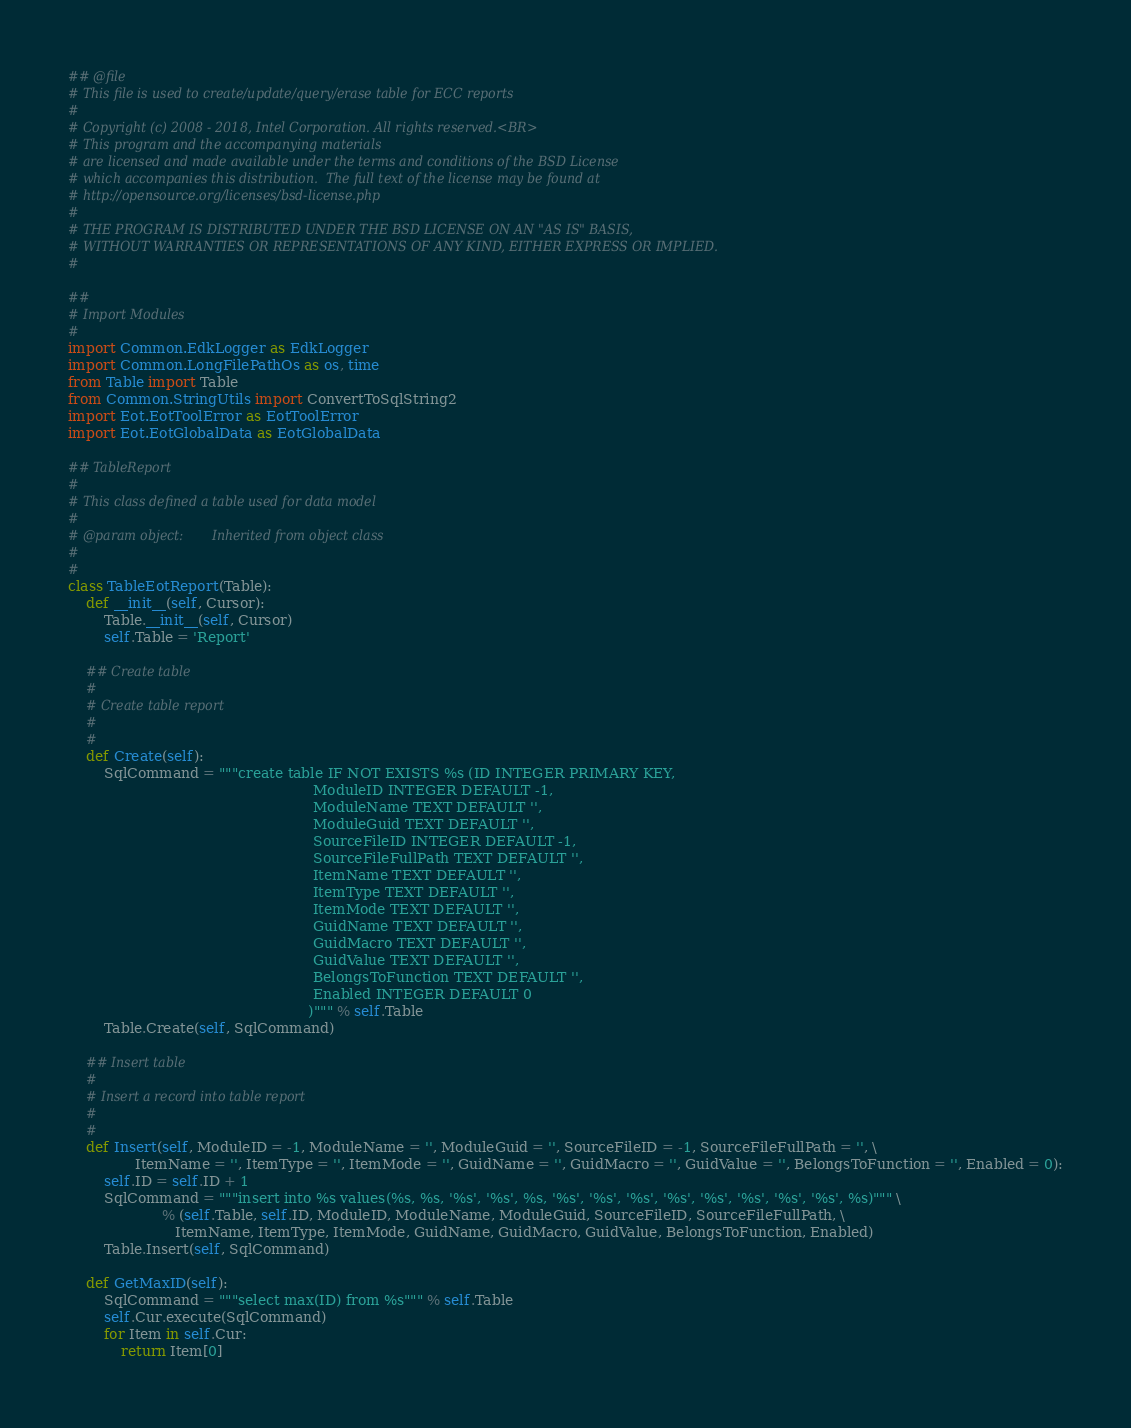Convert code to text. <code><loc_0><loc_0><loc_500><loc_500><_Python_>## @file
# This file is used to create/update/query/erase table for ECC reports
#
# Copyright (c) 2008 - 2018, Intel Corporation. All rights reserved.<BR>
# This program and the accompanying materials
# are licensed and made available under the terms and conditions of the BSD License
# which accompanies this distribution.  The full text of the license may be found at
# http://opensource.org/licenses/bsd-license.php
#
# THE PROGRAM IS DISTRIBUTED UNDER THE BSD LICENSE ON AN "AS IS" BASIS,
# WITHOUT WARRANTIES OR REPRESENTATIONS OF ANY KIND, EITHER EXPRESS OR IMPLIED.
#

##
# Import Modules
#
import Common.EdkLogger as EdkLogger
import Common.LongFilePathOs as os, time
from Table import Table
from Common.StringUtils import ConvertToSqlString2
import Eot.EotToolError as EotToolError
import Eot.EotGlobalData as EotGlobalData

## TableReport
#
# This class defined a table used for data model
#
# @param object:       Inherited from object class
#
#
class TableEotReport(Table):
    def __init__(self, Cursor):
        Table.__init__(self, Cursor)
        self.Table = 'Report'

    ## Create table
    #
    # Create table report
    #
    #
    def Create(self):
        SqlCommand = """create table IF NOT EXISTS %s (ID INTEGER PRIMARY KEY,
                                                       ModuleID INTEGER DEFAULT -1,
                                                       ModuleName TEXT DEFAULT '',
                                                       ModuleGuid TEXT DEFAULT '',
                                                       SourceFileID INTEGER DEFAULT -1,
                                                       SourceFileFullPath TEXT DEFAULT '',
                                                       ItemName TEXT DEFAULT '',
                                                       ItemType TEXT DEFAULT '',
                                                       ItemMode TEXT DEFAULT '',
                                                       GuidName TEXT DEFAULT '',
                                                       GuidMacro TEXT DEFAULT '',
                                                       GuidValue TEXT DEFAULT '',
                                                       BelongsToFunction TEXT DEFAULT '',
                                                       Enabled INTEGER DEFAULT 0
                                                      )""" % self.Table
        Table.Create(self, SqlCommand)

    ## Insert table
    #
    # Insert a record into table report
    #
    #
    def Insert(self, ModuleID = -1, ModuleName = '', ModuleGuid = '', SourceFileID = -1, SourceFileFullPath = '', \
               ItemName = '', ItemType = '', ItemMode = '', GuidName = '', GuidMacro = '', GuidValue = '', BelongsToFunction = '', Enabled = 0):
        self.ID = self.ID + 1
        SqlCommand = """insert into %s values(%s, %s, '%s', '%s', %s, '%s', '%s', '%s', '%s', '%s', '%s', '%s', '%s', %s)""" \
                     % (self.Table, self.ID, ModuleID, ModuleName, ModuleGuid, SourceFileID, SourceFileFullPath, \
                        ItemName, ItemType, ItemMode, GuidName, GuidMacro, GuidValue, BelongsToFunction, Enabled)
        Table.Insert(self, SqlCommand)

    def GetMaxID(self):
        SqlCommand = """select max(ID) from %s""" % self.Table
        self.Cur.execute(SqlCommand)
        for Item in self.Cur:
            return Item[0]
</code> 